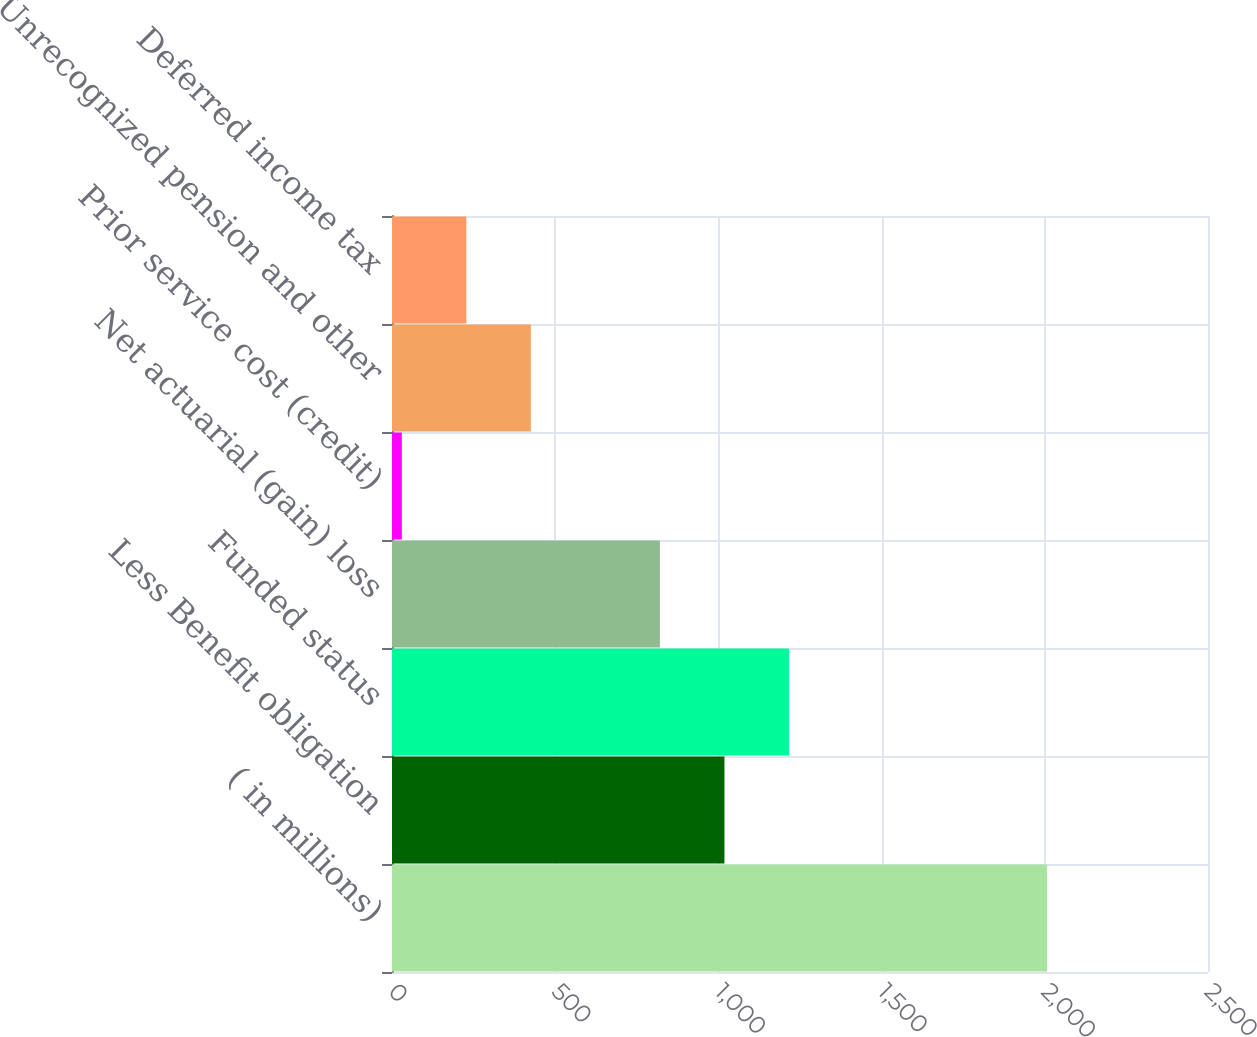Convert chart to OTSL. <chart><loc_0><loc_0><loc_500><loc_500><bar_chart><fcel>( in millions)<fcel>Less Benefit obligation<fcel>Funded status<fcel>Net actuarial (gain) loss<fcel>Prior service cost (credit)<fcel>Unrecognized pension and other<fcel>Deferred income tax<nl><fcel>2007<fcel>1018.5<fcel>1216.2<fcel>820.8<fcel>30<fcel>425.4<fcel>227.7<nl></chart> 